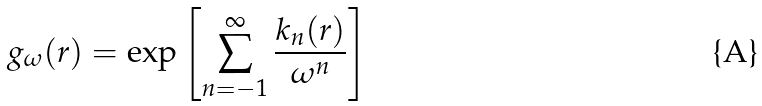<formula> <loc_0><loc_0><loc_500><loc_500>g _ { \omega } ( r ) = \exp \left [ \sum _ { n = - 1 } ^ { \infty } \frac { k _ { n } ( r ) } { \omega ^ { n } } \right ]</formula> 